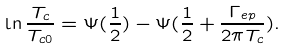Convert formula to latex. <formula><loc_0><loc_0><loc_500><loc_500>\ln \frac { T _ { c } } { T _ { c 0 } } = \Psi ( \frac { 1 } { 2 } ) - \Psi ( \frac { 1 } { 2 } + \frac { \Gamma _ { e p } } { 2 \pi T _ { c } } ) .</formula> 